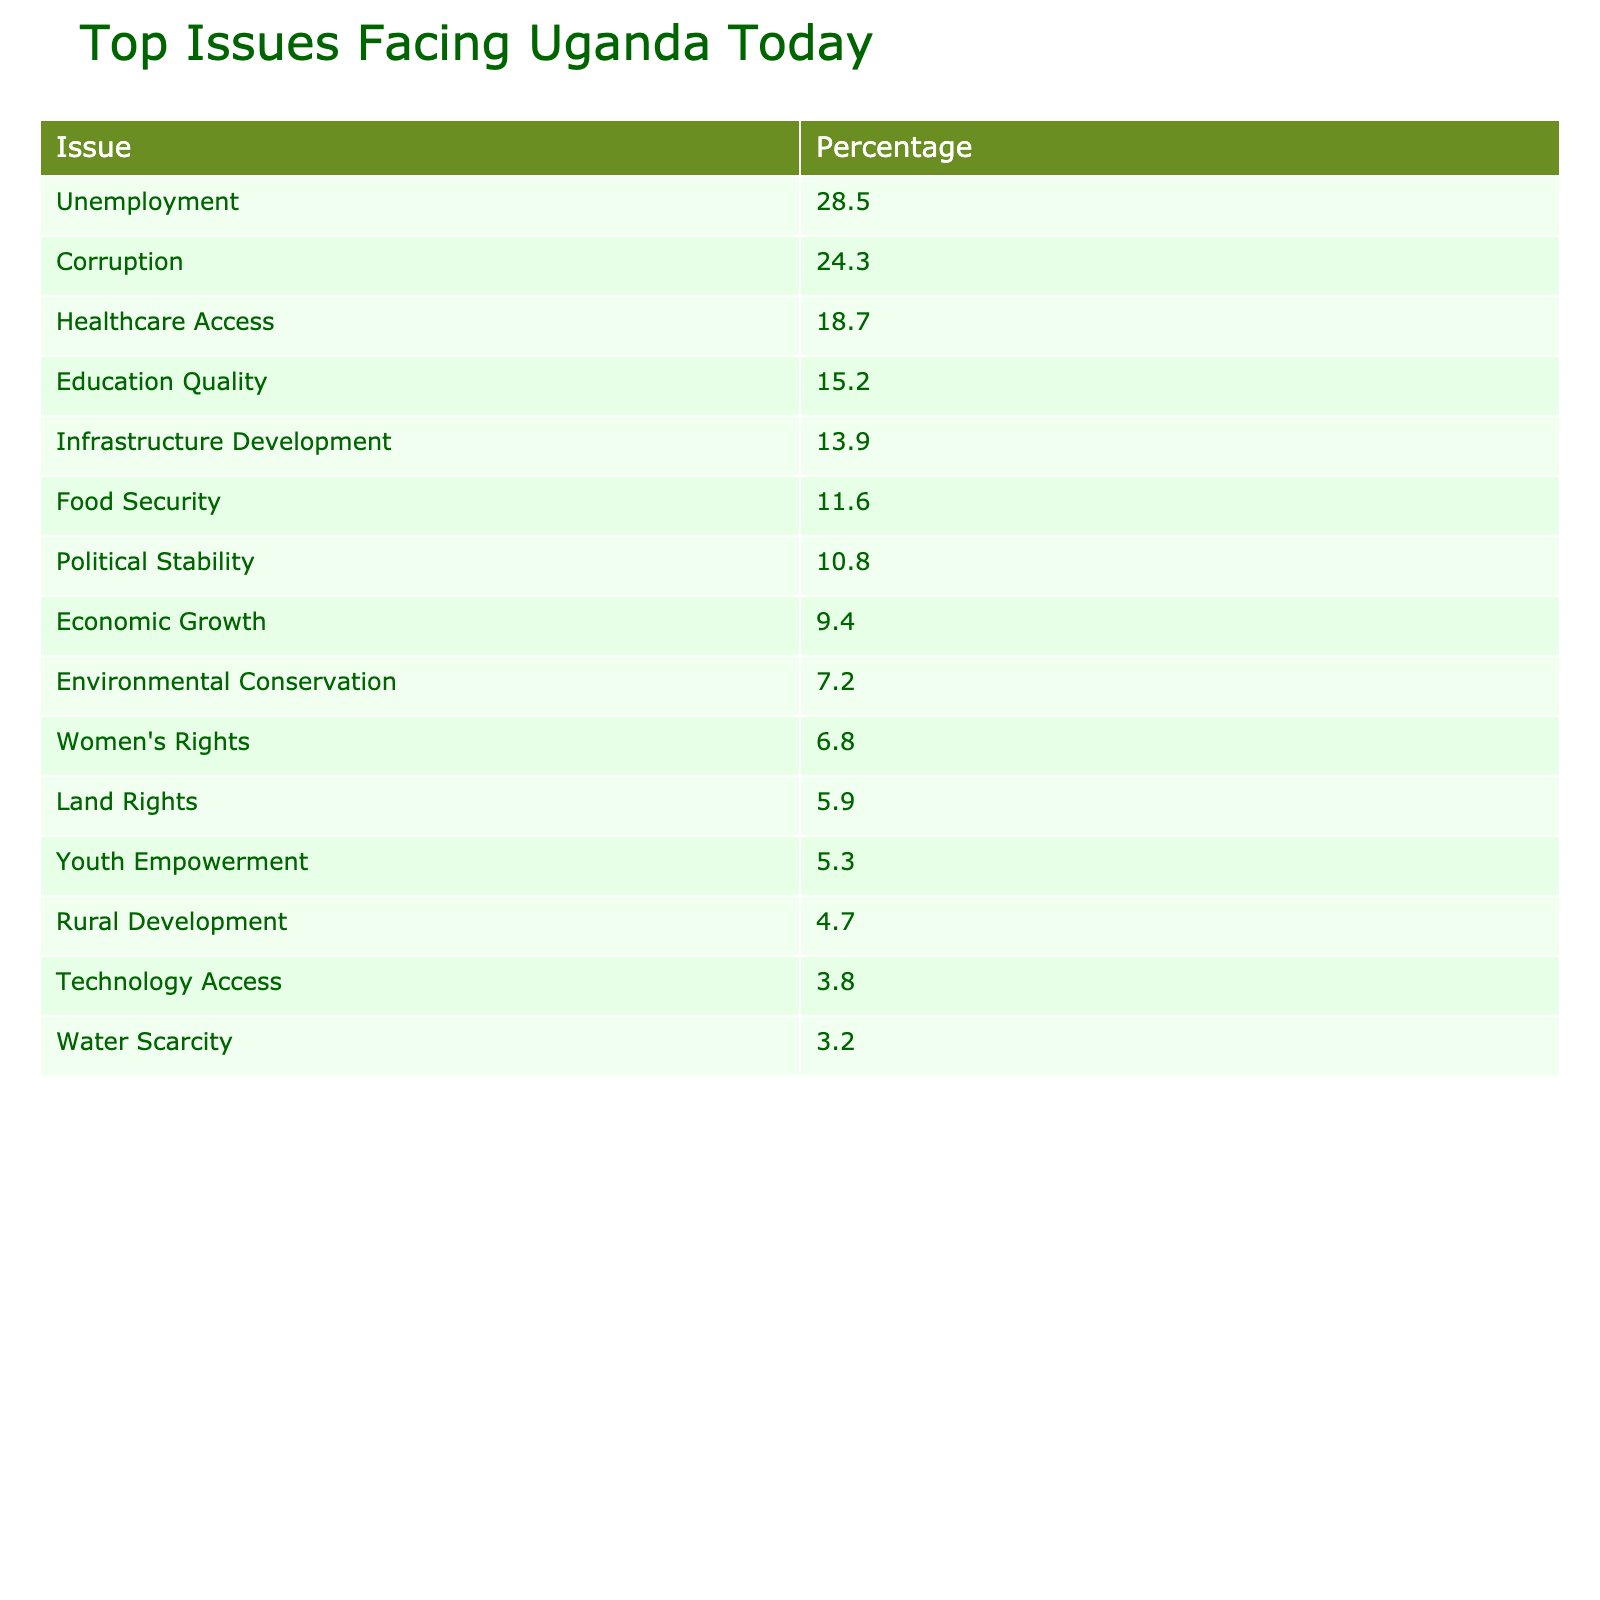What is the most pressing issue facing Uganda according to the poll? The table indicates that the issue with the highest percentage is Unemployment at 28.5%.
Answer: Unemployment What percentage of respondents believe that Corruption is a top issue? The table shows that 24.3% of respondents view Corruption as a top issue facing Uganda today.
Answer: 24.3% Which two issues combined represent over 50% of the public opinion? Adding the percentages of Unemployment (28.5%) and Corruption (24.3%) gives 52.8%, which is over 50%.
Answer: Yes What is the least concerning issue according to the poll results? The data shows that Technology Access has the lowest percentage at 3.8%.
Answer: Technology Access What is the difference in percentage between Healthcare Access and Education Quality? Healthcare Access is at 18.7% and Education Quality is at 15.2%. The difference is 18.7% - 15.2% = 3.5%.
Answer: 3.5% If we consider the top three issues, what is their combined percentage? Adding the top three issues: Unemployment (28.5%) + Corruption (24.3%) + Healthcare Access (18.7%) equals 71.5%.
Answer: 71.5% Does the data suggest that Women's Rights have more concern than Land Rights? Women's Rights have a percentage of 6.8%, while Land Rights have 5.9%. Since 6.8% is greater than 5.9%, the assertion is true.
Answer: Yes What percentage of respondents are concerned about issues related to Rural Development and Technology Access combined? Rural Development is at 4.7% and Technology Access is 3.8%. Thus, 4.7% + 3.8% = 8.5%.
Answer: 8.5% Is Political Stability seen as more critical than Economic Growth? Political Stability has a percentage of 10.8%, while Economic Growth has 9.4%. Since 10.8% is higher than 9.4%, the statement is true.
Answer: Yes What single issue has more concern than both Food Security and Youth Empowerment? Food Security is at 11.6% and Youth Empowerment is at 5.3%. Since Unemployment (28.5%) is greater than both, it fits the criteria.
Answer: Unemployment 